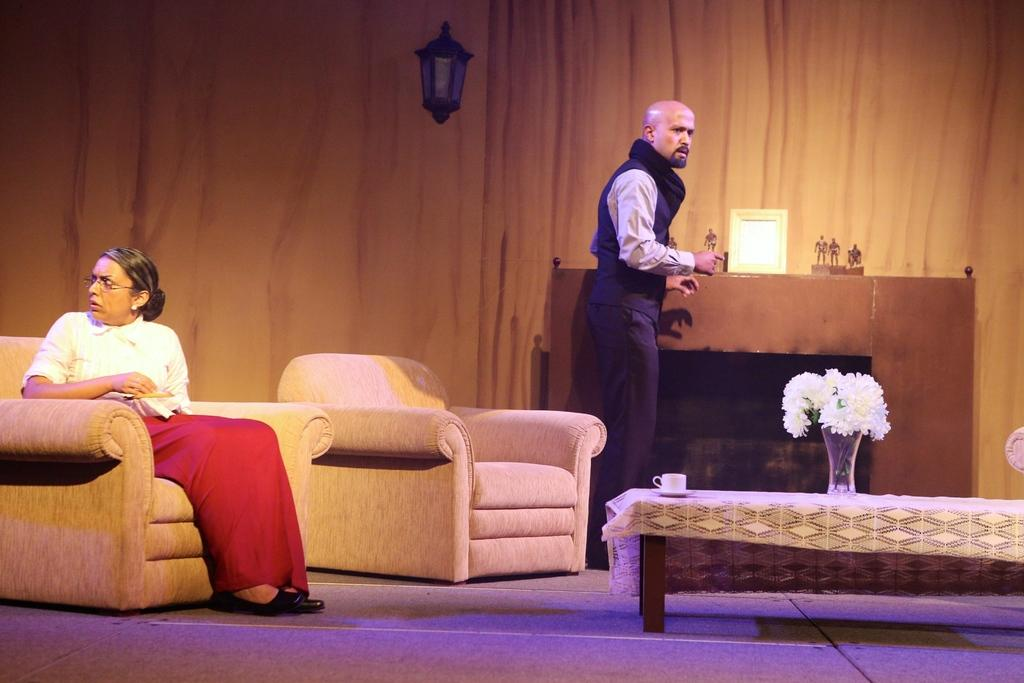How many people are in the image? There are two people in the image, a man and a woman. What is the woman doing in the image? The woman is seated in a chair. What is the man doing in relation to the woman? The man is standing on the woman. What is present on the table in the image? There is a cup and a flower pot on the table. What type of calculator is on the table in the image? There is no calculator present in the image. What color is the cream on the table in the image? There is no cream present in the image. 